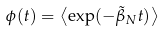Convert formula to latex. <formula><loc_0><loc_0><loc_500><loc_500>\phi ( t ) = \left \langle \exp ( - { \tilde { \beta } } _ { N } t ) \right \rangle</formula> 